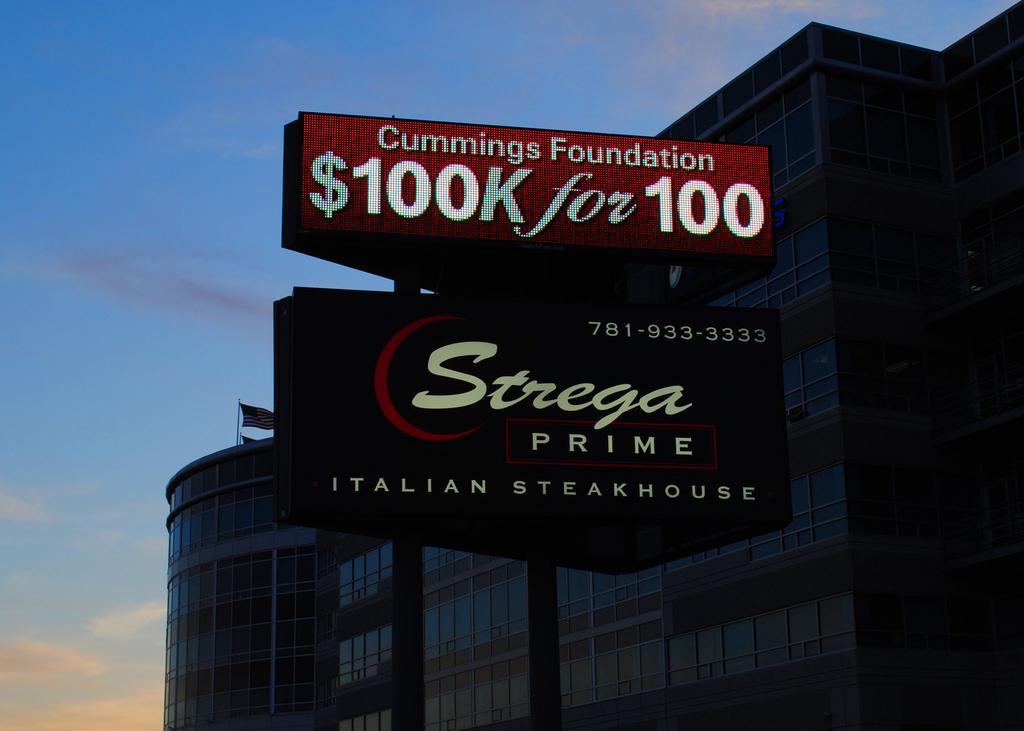Provide a one-sentence caption for the provided image. A sign for compensation claims sits above another sign for a steakhouse in front of a large building at dusk. 